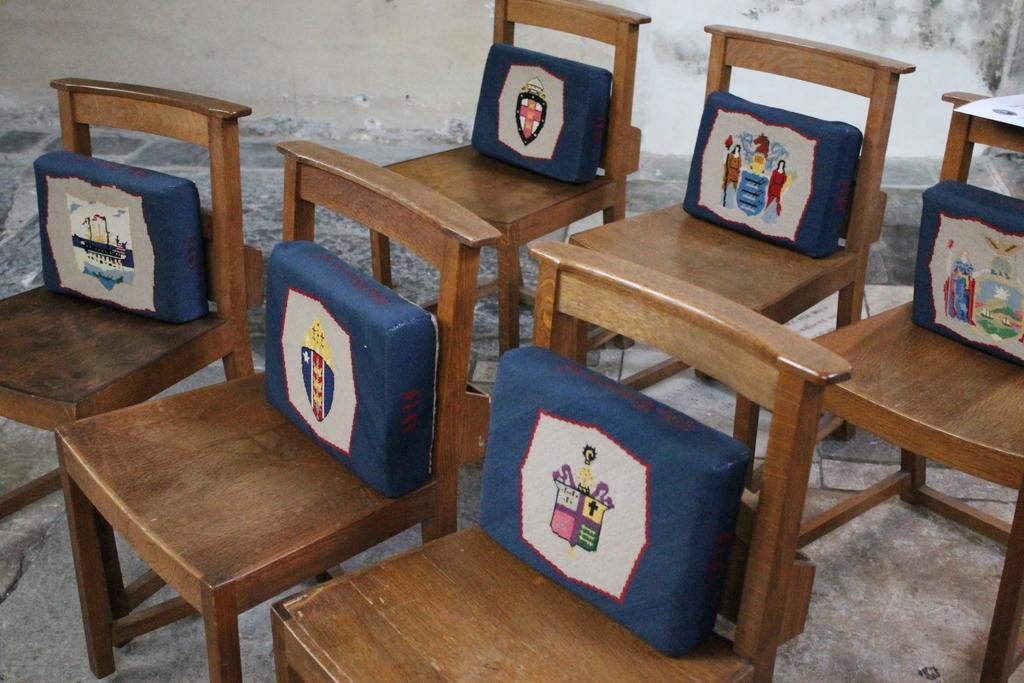Please provide a concise description of this image. In this picture I can see there are few wooden chairs and there are few cushions placed on the chairs and they have some symbols on it. In the backdrop there is a wall. 